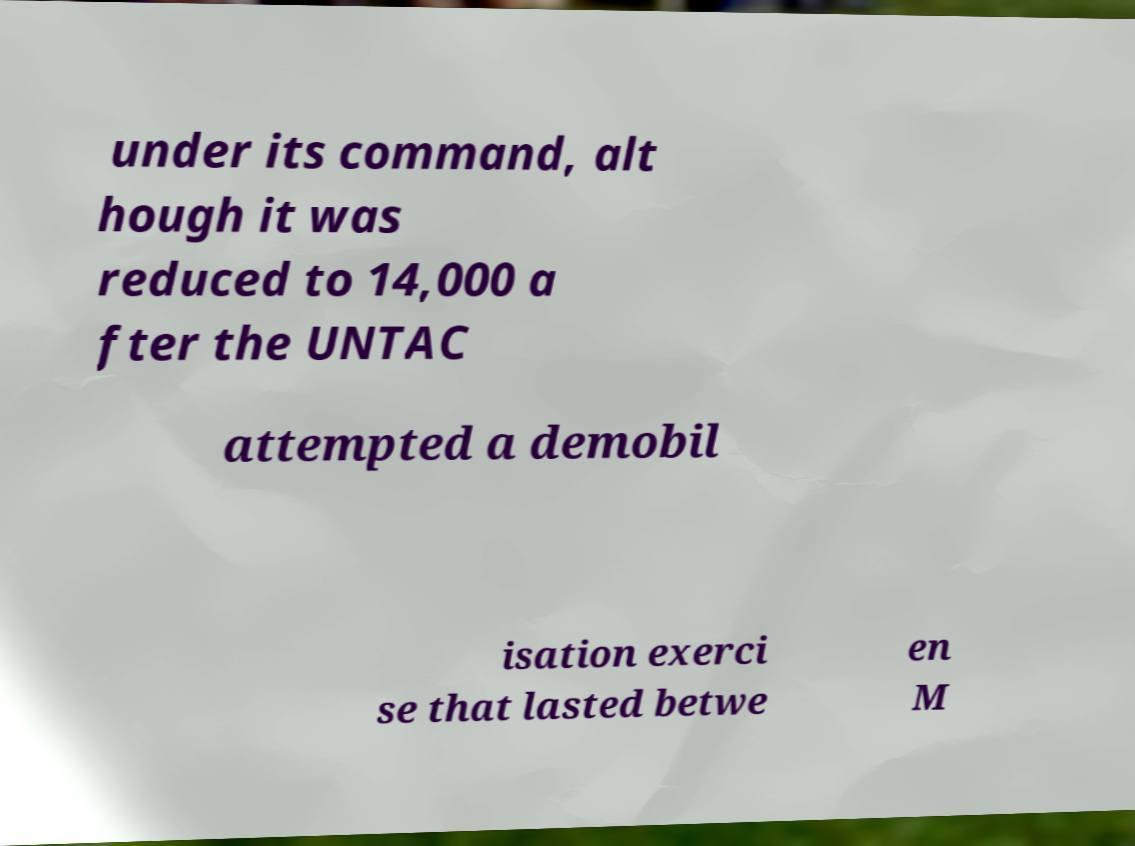For documentation purposes, I need the text within this image transcribed. Could you provide that? under its command, alt hough it was reduced to 14,000 a fter the UNTAC attempted a demobil isation exerci se that lasted betwe en M 